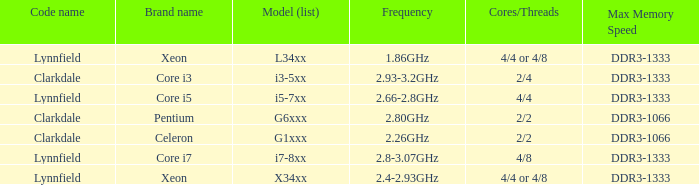What brand is model G6xxx? Pentium. 